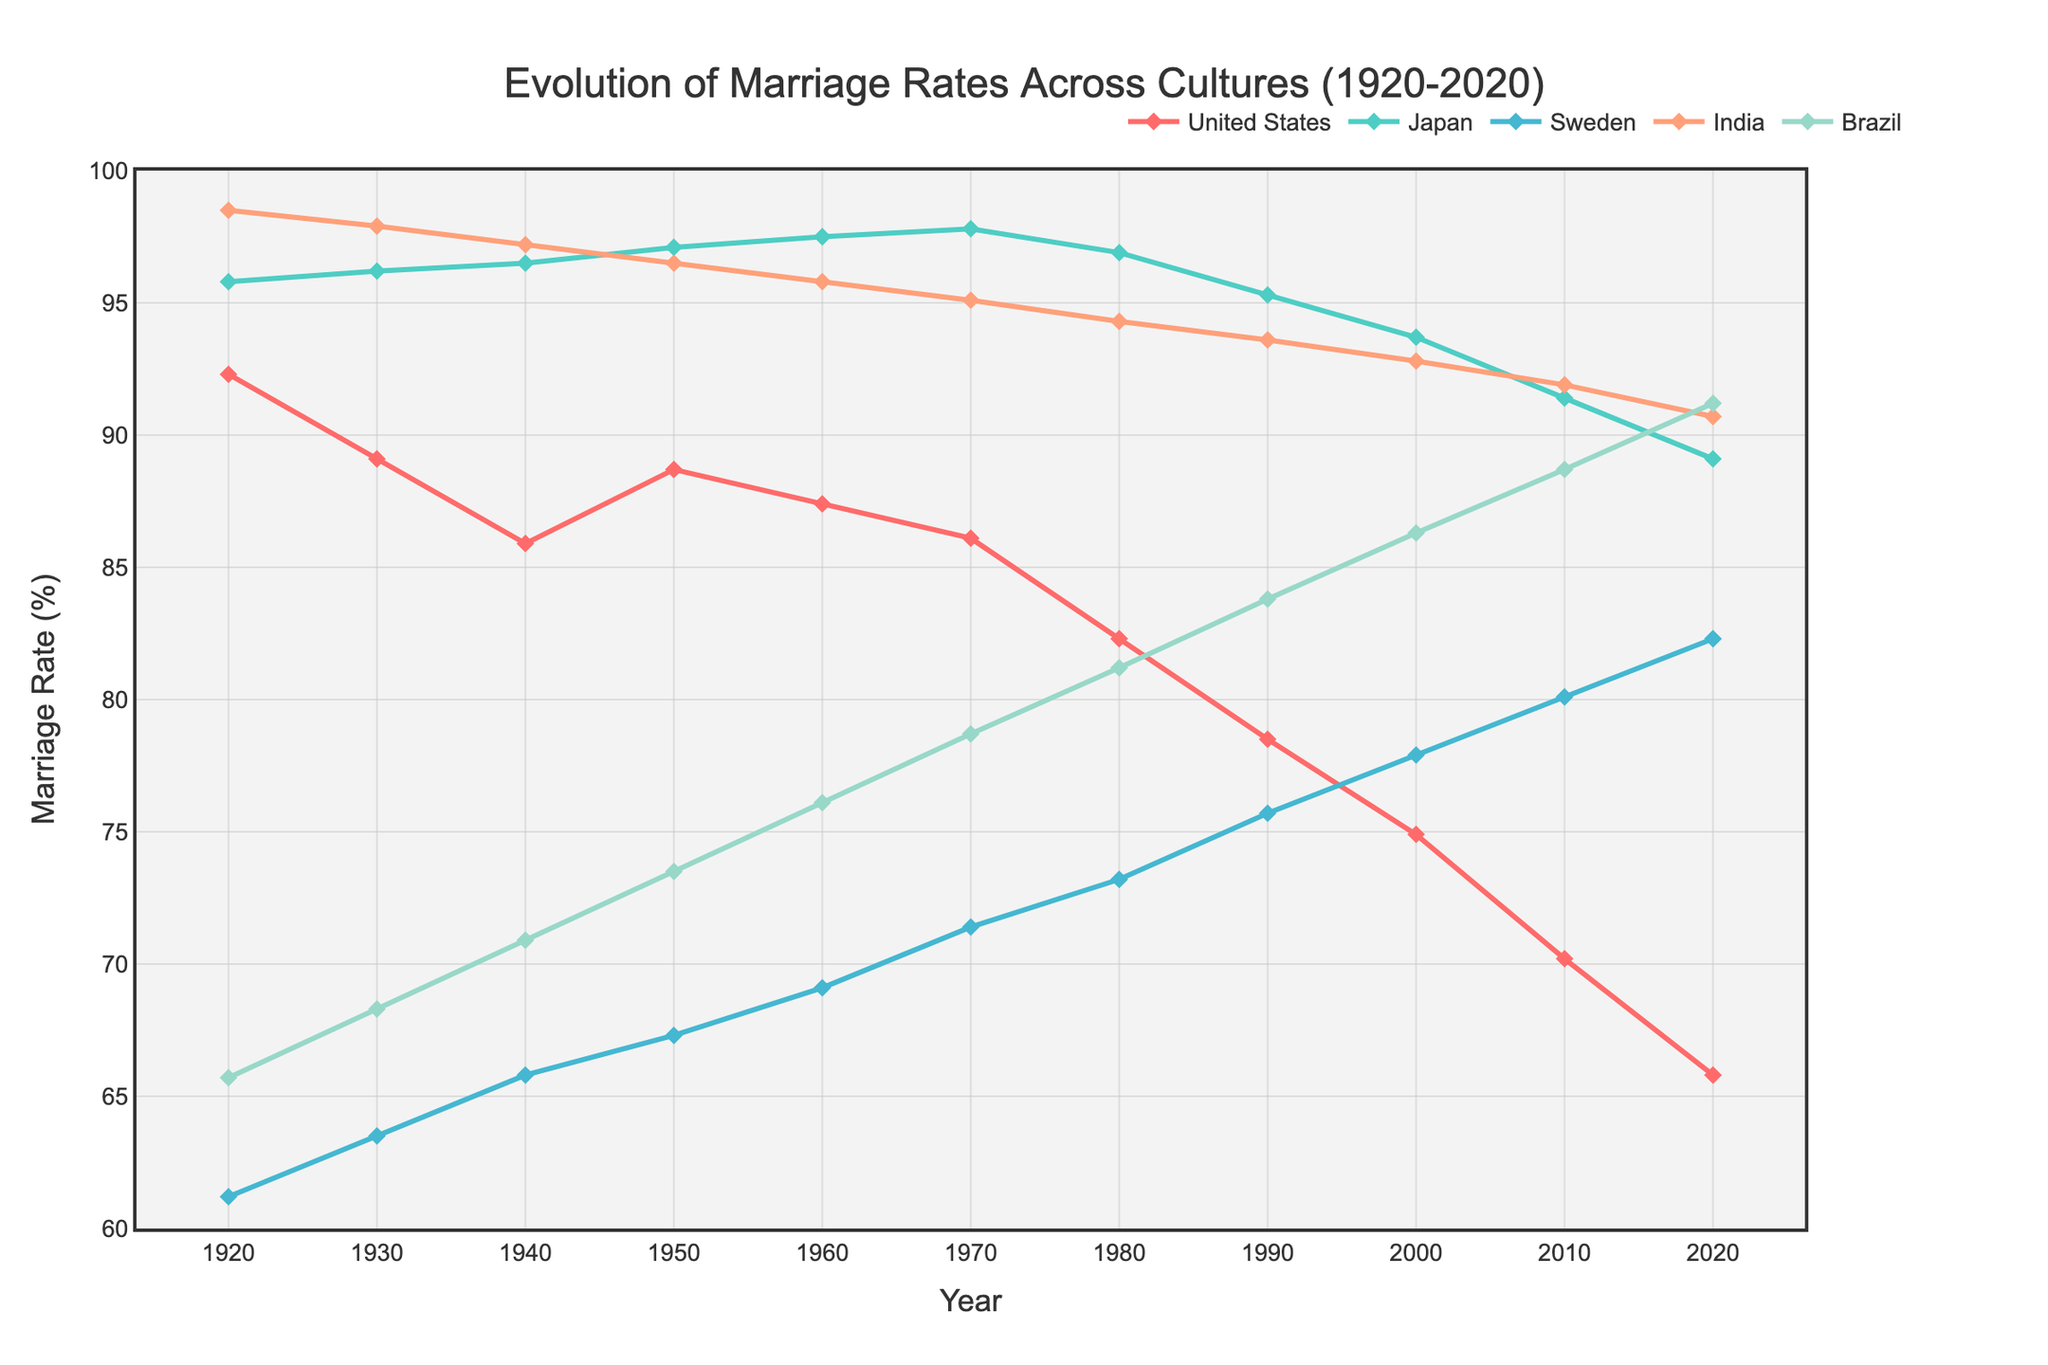What was the marriage rate in Japan in 1950? Look for the data point on the line corresponding to Japan in 1950. The plot shows this as 97.1%.
Answer: 97.1% How did the marriage rate in the United States change from 1920 to 2020? Find the corresponding points on the line for the United States in 1920 and 2020. The rate dropped from 92.3% in 1920 to 65.8% in 2020.
Answer: Dropped by 26.5% Which country had the highest marriage rate in 2020? Compare the endpoints for all the countries in 2020. India shows the highest value at 90.7%.
Answer: India What was the average marriage rate across all countries in 1970? Add the marriage rates for all countries in 1970 and divide by the number of countries. (86.1 + 97.8 + 71.4 + 95.1 + 78.7) / 5 = 429.1 / 5 = 85.82
Answer: 85.82% Did the marriage rate in Sweden ever surpass that of Brazil between 1920 and 2020? Look at the lines for Sweden and Brazil and compare their positions over time. The marriage rate for Sweden was always lower than Brazil's throughout this period.
Answer: No Between which years did India experience the highest drop in marriage rate, and what is the percentage drop? Compare the marriage rate drops between consecutive decades for India. The biggest drop is between 1950 (96.5%) and 1960 (95.8%), giving a drop of 0.7%.
Answer: 1950 to 1960, 0.7% In which decade did Japan see the least change in its marriage rates? Look at the changes in the marriage rates for Japan across each decade. From 1940 to 1950, the change is 96.5% to 97.1%, which is an increase of only 0.6%.
Answer: 1940s (only increased by 0.6%) Which country shows the steadiest decline in marriage rates over the past century? Look for the country line with the most consistent downward trend. The United States shows a continuous decline from 1920 to 2020.
Answer: United States How has the marriage rate in Brazil changed from 1980 to 2020? Find the data points for Brazil in 1980 and 2020. The rate increased from 81.2% to 91.2%.
Answer: Increased by 10% In which decade did Sweden experience the highest marriage rate change, and by how much? Compare the changes in Sweden's marriage rates across each decade. The biggest change is from 1920 (61.2%) to 1930 (63.5%), which is an increase of 2.3%.
Answer: 1920-1930, 2.3% 